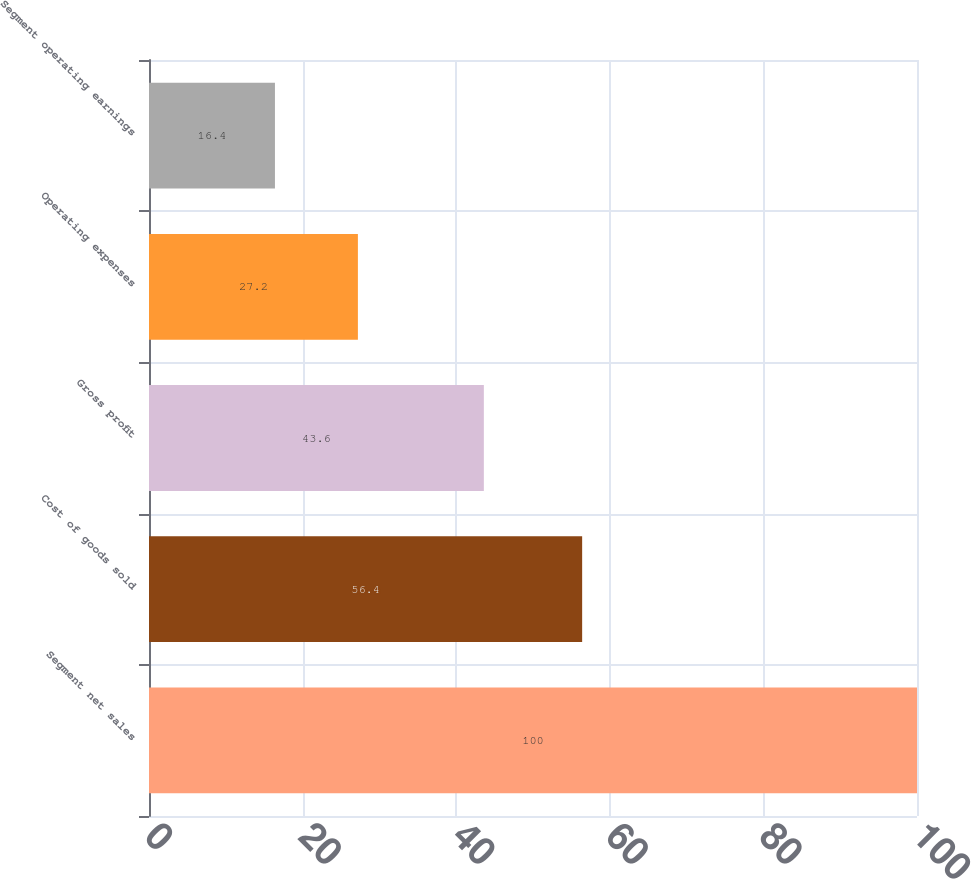Convert chart to OTSL. <chart><loc_0><loc_0><loc_500><loc_500><bar_chart><fcel>Segment net sales<fcel>Cost of goods sold<fcel>Gross profit<fcel>Operating expenses<fcel>Segment operating earnings<nl><fcel>100<fcel>56.4<fcel>43.6<fcel>27.2<fcel>16.4<nl></chart> 